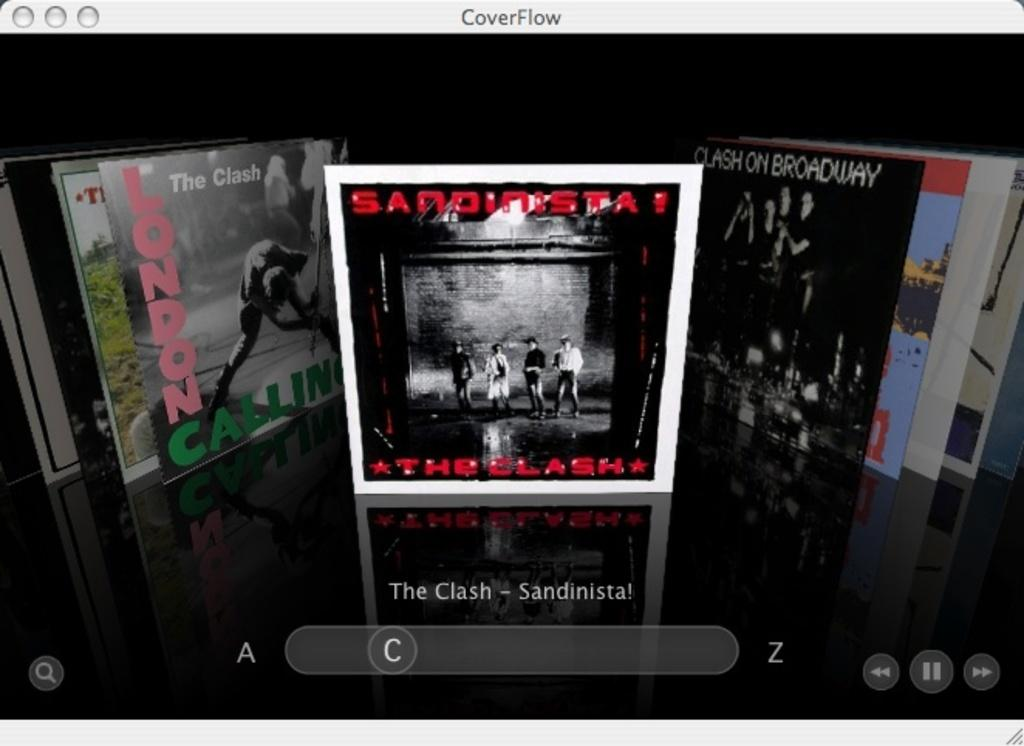Provide a one-sentence caption for the provided image. The album art for an album by The Clash is shown. 